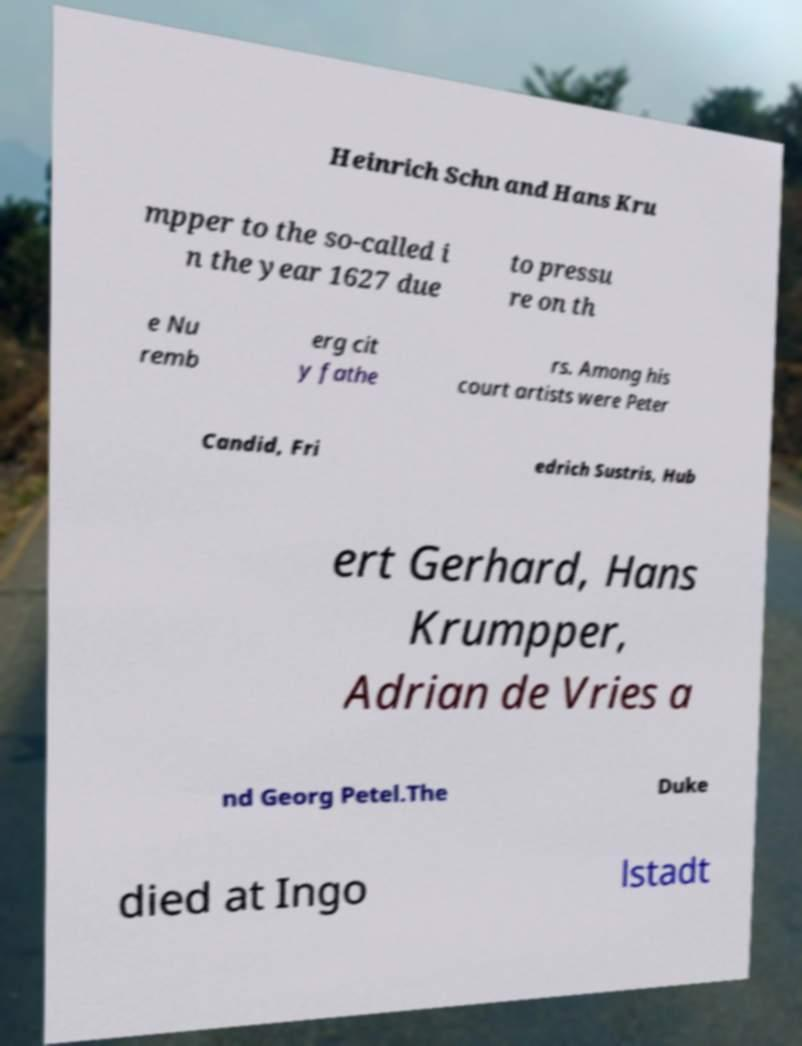Can you accurately transcribe the text from the provided image for me? Heinrich Schn and Hans Kru mpper to the so-called i n the year 1627 due to pressu re on th e Nu remb erg cit y fathe rs. Among his court artists were Peter Candid, Fri edrich Sustris, Hub ert Gerhard, Hans Krumpper, Adrian de Vries a nd Georg Petel.The Duke died at Ingo lstadt 